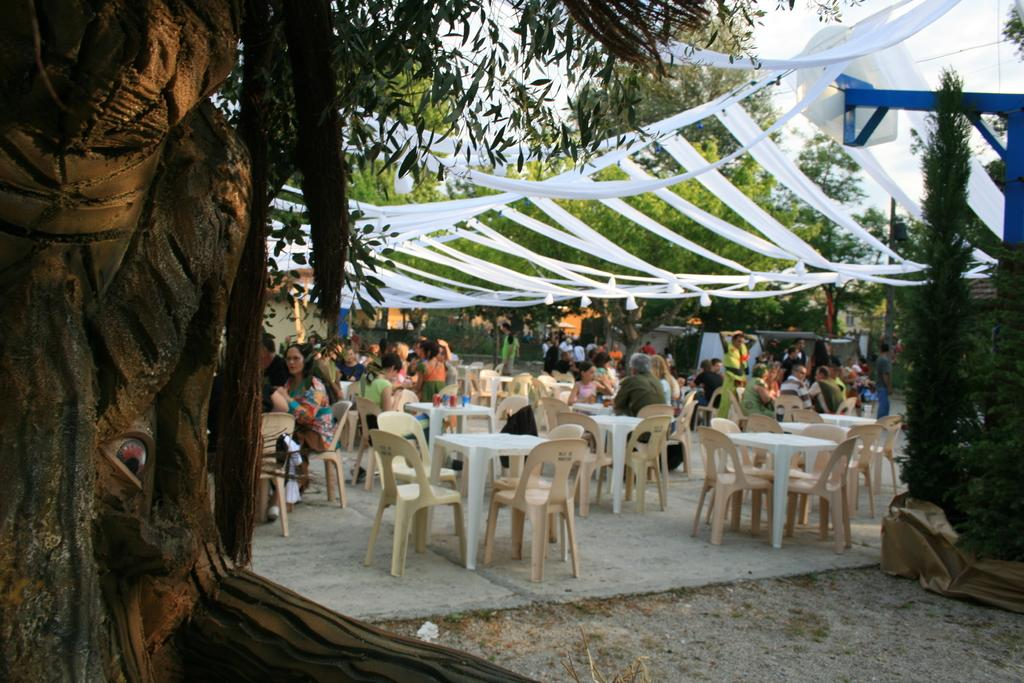What are the people in the image doing? The people in the image are sitting in chairs around tables. What is covering the tables in the image? There is cloth tied across the tables. What can be seen in the background of the image? There are trees and the sky visible in the background of the image. What type of berry is being used as a limit for the operation in the image? There is no berry or operation present in the image. 